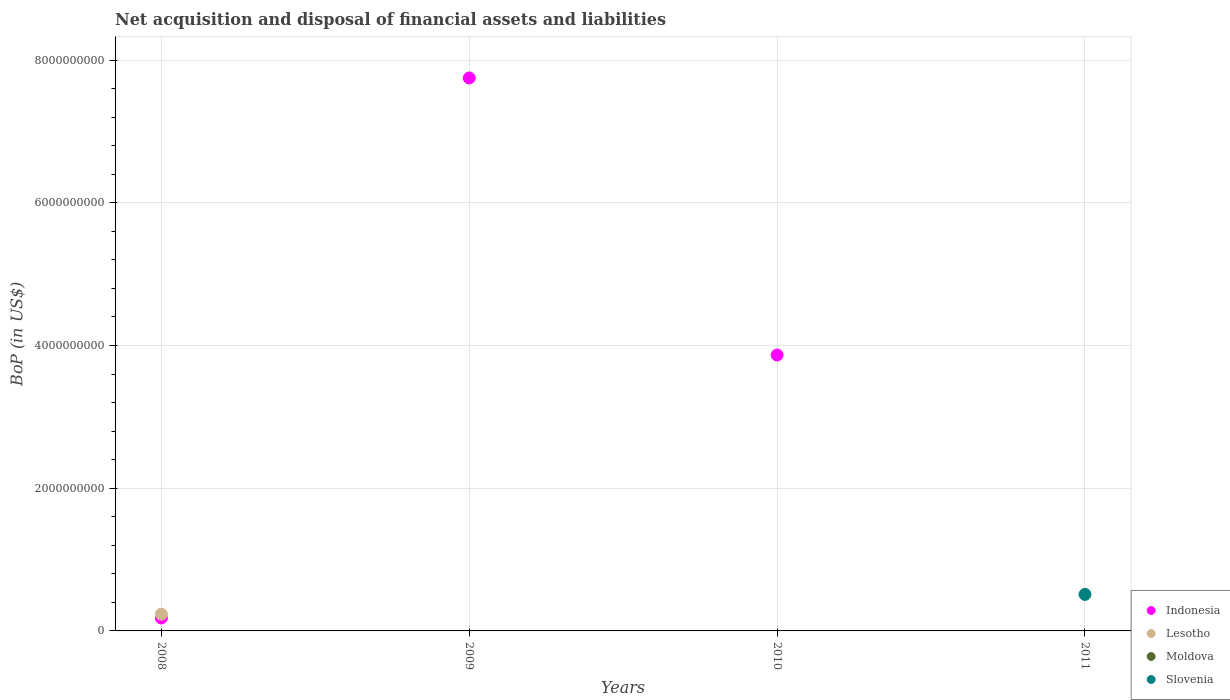Is the number of dotlines equal to the number of legend labels?
Provide a succinct answer. No. Across all years, what is the maximum Balance of Payments in Indonesia?
Ensure brevity in your answer.  7.75e+09. Across all years, what is the minimum Balance of Payments in Moldova?
Your answer should be very brief. 0. What is the total Balance of Payments in Indonesia in the graph?
Give a very brief answer. 1.18e+1. What is the difference between the Balance of Payments in Indonesia in 2008 and that in 2010?
Your answer should be very brief. -3.69e+09. What is the difference between the Balance of Payments in Moldova in 2009 and the Balance of Payments in Lesotho in 2008?
Ensure brevity in your answer.  -2.34e+08. What is the average Balance of Payments in Moldova per year?
Provide a short and direct response. 0. In how many years, is the Balance of Payments in Slovenia greater than 400000000 US$?
Ensure brevity in your answer.  1. What is the ratio of the Balance of Payments in Indonesia in 2008 to that in 2009?
Give a very brief answer. 0.02. Is the Balance of Payments in Indonesia in 2008 less than that in 2009?
Keep it short and to the point. Yes. What is the difference between the highest and the second highest Balance of Payments in Indonesia?
Give a very brief answer. 3.88e+09. What is the difference between the highest and the lowest Balance of Payments in Lesotho?
Your answer should be compact. 2.34e+08. In how many years, is the Balance of Payments in Moldova greater than the average Balance of Payments in Moldova taken over all years?
Your answer should be compact. 0. Is the sum of the Balance of Payments in Indonesia in 2008 and 2009 greater than the maximum Balance of Payments in Lesotho across all years?
Ensure brevity in your answer.  Yes. Is it the case that in every year, the sum of the Balance of Payments in Lesotho and Balance of Payments in Moldova  is greater than the sum of Balance of Payments in Slovenia and Balance of Payments in Indonesia?
Keep it short and to the point. No. Is the Balance of Payments in Slovenia strictly greater than the Balance of Payments in Lesotho over the years?
Provide a succinct answer. No. How many dotlines are there?
Give a very brief answer. 3. How many years are there in the graph?
Ensure brevity in your answer.  4. What is the difference between two consecutive major ticks on the Y-axis?
Give a very brief answer. 2.00e+09. Are the values on the major ticks of Y-axis written in scientific E-notation?
Ensure brevity in your answer.  No. Does the graph contain grids?
Your answer should be compact. Yes. How are the legend labels stacked?
Your answer should be compact. Vertical. What is the title of the graph?
Provide a short and direct response. Net acquisition and disposal of financial assets and liabilities. What is the label or title of the Y-axis?
Give a very brief answer. BoP (in US$). What is the BoP (in US$) of Indonesia in 2008?
Offer a terse response. 1.82e+08. What is the BoP (in US$) in Lesotho in 2008?
Your answer should be compact. 2.34e+08. What is the BoP (in US$) in Indonesia in 2009?
Provide a succinct answer. 7.75e+09. What is the BoP (in US$) of Lesotho in 2009?
Ensure brevity in your answer.  0. What is the BoP (in US$) of Moldova in 2009?
Give a very brief answer. 0. What is the BoP (in US$) of Indonesia in 2010?
Ensure brevity in your answer.  3.87e+09. What is the BoP (in US$) of Lesotho in 2010?
Your answer should be very brief. 0. What is the BoP (in US$) in Indonesia in 2011?
Your response must be concise. 0. What is the BoP (in US$) of Lesotho in 2011?
Make the answer very short. 0. What is the BoP (in US$) of Moldova in 2011?
Your answer should be compact. 0. What is the BoP (in US$) in Slovenia in 2011?
Your answer should be very brief. 5.12e+08. Across all years, what is the maximum BoP (in US$) in Indonesia?
Your answer should be compact. 7.75e+09. Across all years, what is the maximum BoP (in US$) of Lesotho?
Offer a terse response. 2.34e+08. Across all years, what is the maximum BoP (in US$) in Slovenia?
Offer a very short reply. 5.12e+08. Across all years, what is the minimum BoP (in US$) of Lesotho?
Ensure brevity in your answer.  0. What is the total BoP (in US$) in Indonesia in the graph?
Provide a succinct answer. 1.18e+1. What is the total BoP (in US$) in Lesotho in the graph?
Give a very brief answer. 2.34e+08. What is the total BoP (in US$) in Slovenia in the graph?
Offer a very short reply. 5.12e+08. What is the difference between the BoP (in US$) in Indonesia in 2008 and that in 2009?
Provide a short and direct response. -7.57e+09. What is the difference between the BoP (in US$) of Indonesia in 2008 and that in 2010?
Your response must be concise. -3.69e+09. What is the difference between the BoP (in US$) of Indonesia in 2009 and that in 2010?
Give a very brief answer. 3.88e+09. What is the difference between the BoP (in US$) of Indonesia in 2008 and the BoP (in US$) of Slovenia in 2011?
Provide a short and direct response. -3.30e+08. What is the difference between the BoP (in US$) of Lesotho in 2008 and the BoP (in US$) of Slovenia in 2011?
Provide a succinct answer. -2.77e+08. What is the difference between the BoP (in US$) in Indonesia in 2009 and the BoP (in US$) in Slovenia in 2011?
Your answer should be very brief. 7.24e+09. What is the difference between the BoP (in US$) in Indonesia in 2010 and the BoP (in US$) in Slovenia in 2011?
Your response must be concise. 3.36e+09. What is the average BoP (in US$) in Indonesia per year?
Offer a very short reply. 2.95e+09. What is the average BoP (in US$) in Lesotho per year?
Offer a terse response. 5.86e+07. What is the average BoP (in US$) of Slovenia per year?
Offer a very short reply. 1.28e+08. In the year 2008, what is the difference between the BoP (in US$) in Indonesia and BoP (in US$) in Lesotho?
Provide a short and direct response. -5.26e+07. What is the ratio of the BoP (in US$) of Indonesia in 2008 to that in 2009?
Give a very brief answer. 0.02. What is the ratio of the BoP (in US$) of Indonesia in 2008 to that in 2010?
Keep it short and to the point. 0.05. What is the ratio of the BoP (in US$) in Indonesia in 2009 to that in 2010?
Make the answer very short. 2. What is the difference between the highest and the second highest BoP (in US$) in Indonesia?
Provide a short and direct response. 3.88e+09. What is the difference between the highest and the lowest BoP (in US$) of Indonesia?
Ensure brevity in your answer.  7.75e+09. What is the difference between the highest and the lowest BoP (in US$) of Lesotho?
Your answer should be very brief. 2.34e+08. What is the difference between the highest and the lowest BoP (in US$) in Slovenia?
Offer a terse response. 5.12e+08. 